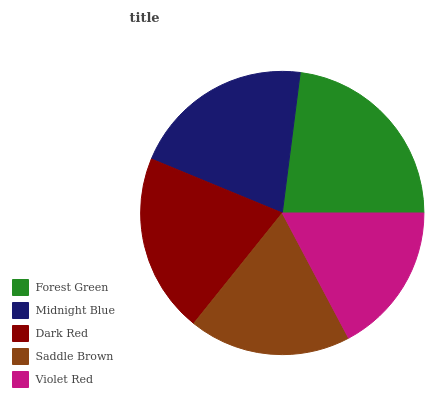Is Violet Red the minimum?
Answer yes or no. Yes. Is Forest Green the maximum?
Answer yes or no. Yes. Is Midnight Blue the minimum?
Answer yes or no. No. Is Midnight Blue the maximum?
Answer yes or no. No. Is Forest Green greater than Midnight Blue?
Answer yes or no. Yes. Is Midnight Blue less than Forest Green?
Answer yes or no. Yes. Is Midnight Blue greater than Forest Green?
Answer yes or no. No. Is Forest Green less than Midnight Blue?
Answer yes or no. No. Is Dark Red the high median?
Answer yes or no. Yes. Is Dark Red the low median?
Answer yes or no. Yes. Is Violet Red the high median?
Answer yes or no. No. Is Midnight Blue the low median?
Answer yes or no. No. 